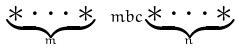Convert formula to latex. <formula><loc_0><loc_0><loc_500><loc_500>\underbrace { * \dots * } _ { m } \ m b c \underbrace { * \dots * } _ { n }</formula> 